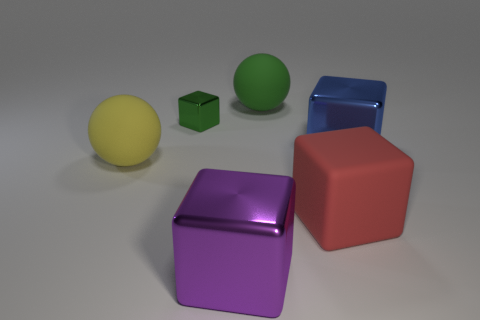Are the big ball in front of the blue metallic cube and the tiny block made of the same material?
Give a very brief answer. No. Is the number of large red rubber things that are in front of the red block the same as the number of large yellow rubber balls that are behind the green block?
Provide a succinct answer. Yes. What size is the rubber object in front of the big rubber ball in front of the green sphere?
Keep it short and to the point. Large. What material is the thing that is both to the left of the red object and in front of the yellow rubber ball?
Offer a terse response. Metal. How many other objects are there of the same size as the green rubber ball?
Ensure brevity in your answer.  4. What color is the rubber cube?
Give a very brief answer. Red. There is a large rubber sphere behind the small green metal cube; does it have the same color as the metallic block that is behind the blue shiny object?
Provide a succinct answer. Yes. How big is the green shiny block?
Make the answer very short. Small. What is the size of the green object on the left side of the large purple block?
Your answer should be very brief. Small. There is a object that is both in front of the large yellow rubber sphere and behind the purple thing; what shape is it?
Make the answer very short. Cube. 